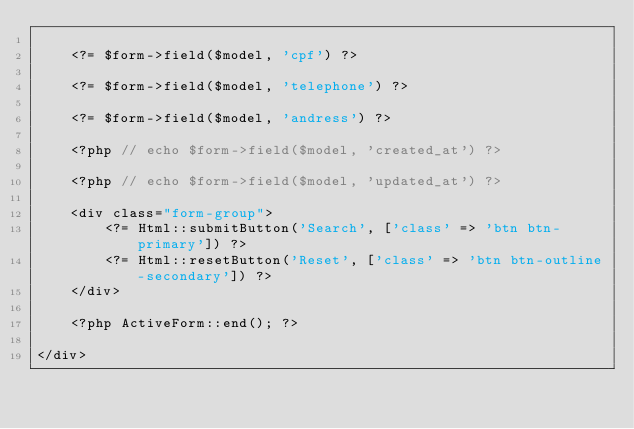<code> <loc_0><loc_0><loc_500><loc_500><_PHP_>
    <?= $form->field($model, 'cpf') ?>

    <?= $form->field($model, 'telephone') ?>

    <?= $form->field($model, 'andress') ?>

    <?php // echo $form->field($model, 'created_at') ?>

    <?php // echo $form->field($model, 'updated_at') ?>

    <div class="form-group">
        <?= Html::submitButton('Search', ['class' => 'btn btn-primary']) ?>
        <?= Html::resetButton('Reset', ['class' => 'btn btn-outline-secondary']) ?>
    </div>

    <?php ActiveForm::end(); ?>

</div>
</code> 